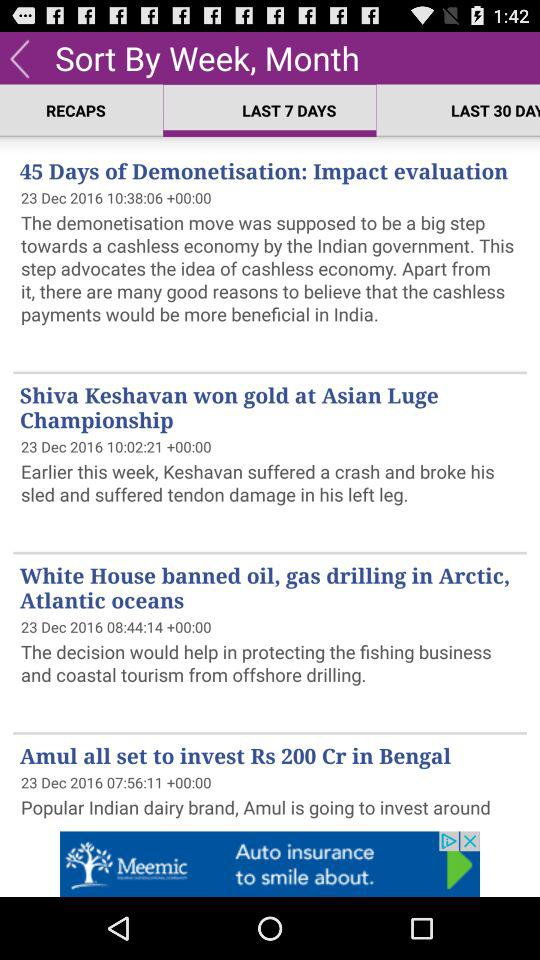Who won the gold at the "Asian Luge Championship"? The gold was won by "Shiva Keshavan". 